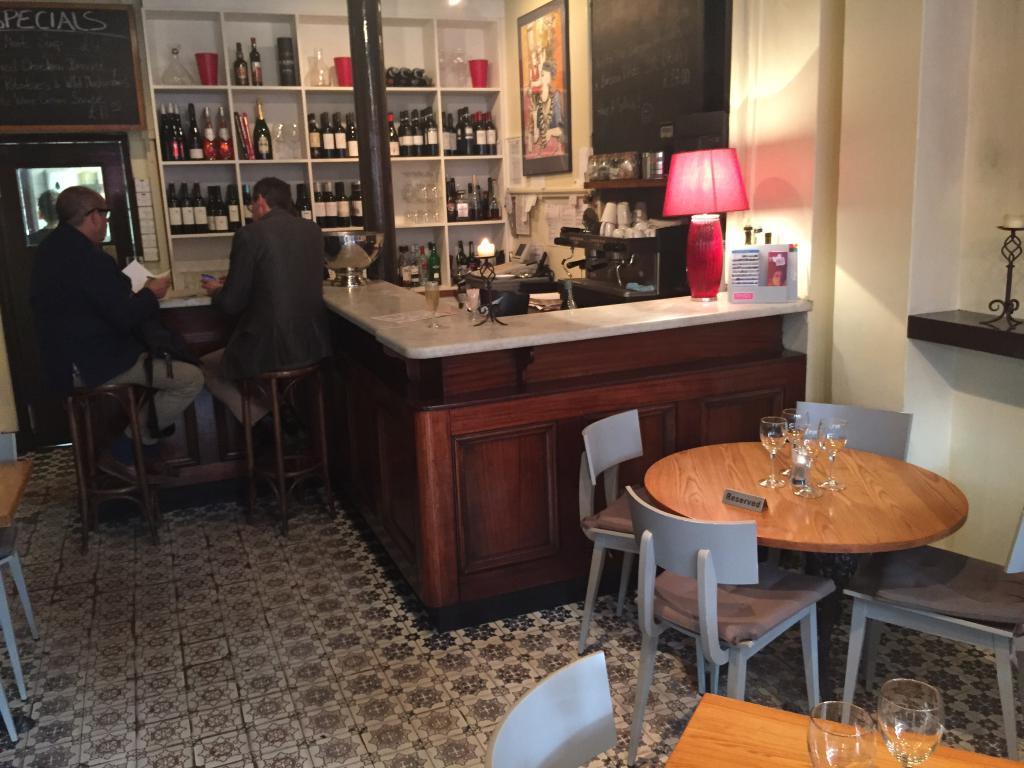How would you summarize this image in a sentence or two? In this image I can see two persons sitting and I can also see few bottles in the racks. In the background I can see the frame attached to the wall and the wall is in cream color. In front I can see few glasses on the table and I can also see few chairs in gray color. 